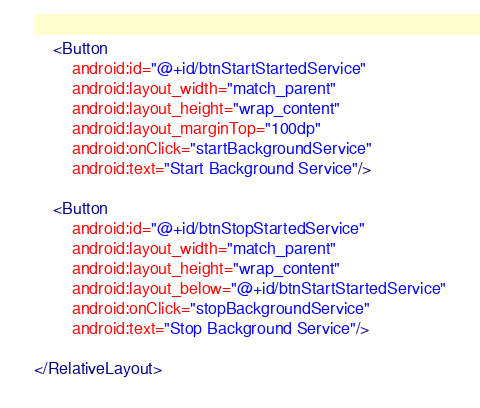<code> <loc_0><loc_0><loc_500><loc_500><_XML_>	<Button
		android:id="@+id/btnStartStartedService"
		android:layout_width="match_parent"
		android:layout_height="wrap_content"
		android:layout_marginTop="100dp"
		android:onClick="startBackgroundService"
		android:text="Start Background Service"/>

	<Button
		android:id="@+id/btnStopStartedService"
		android:layout_width="match_parent"
		android:layout_height="wrap_content"
		android:layout_below="@+id/btnStartStartedService"
		android:onClick="stopBackgroundService"
		android:text="Stop Background Service"/>

</RelativeLayout>
</code> 